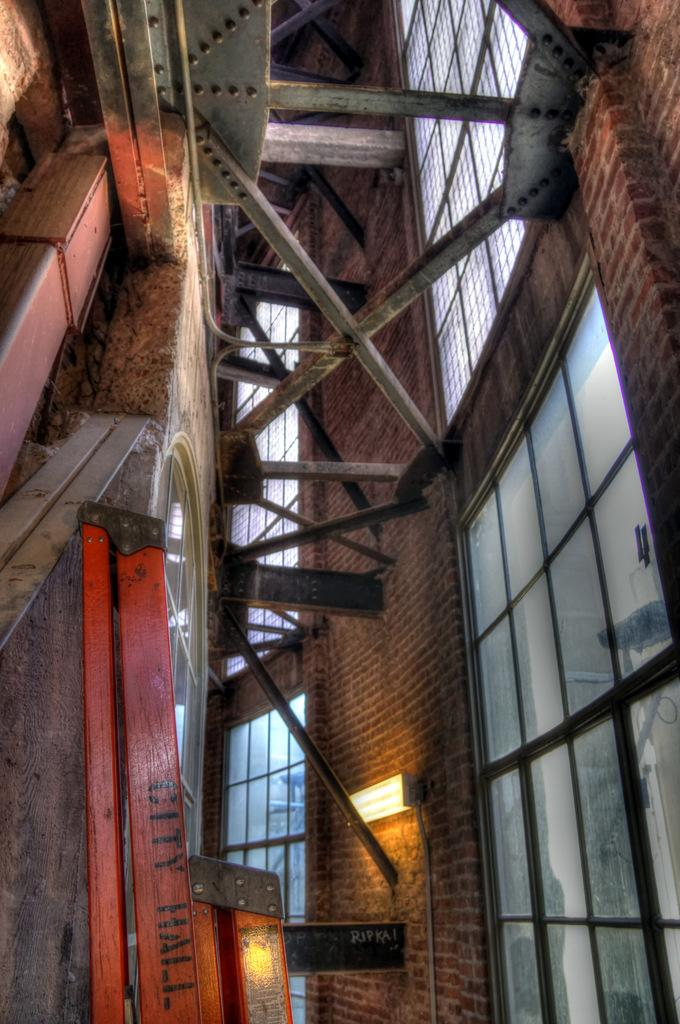What type of structure is shown in the image? The image depicts an internal structure of a building. What material are the windows made of in the image? The windows in the image are made of glass. What type of support can be seen in the image? There are wooden poles in the image. Is there any source of light visible in the image? Yes, there is a light in the image. What type of song can be heard playing in the background of the image? There is no sound or music present in the image, so it is not possible to determine what song might be playing. 